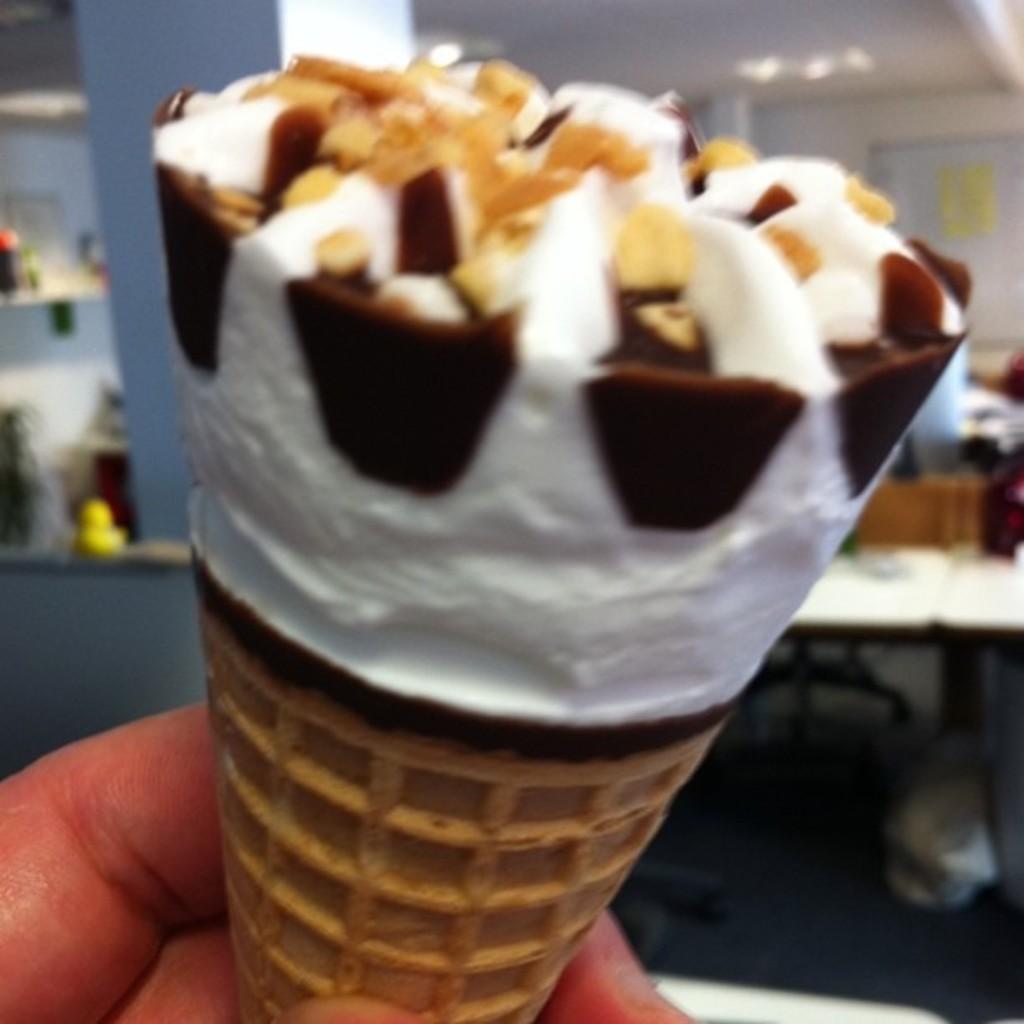Please provide a concise description of this image. A human hand is holding an ice cream. 